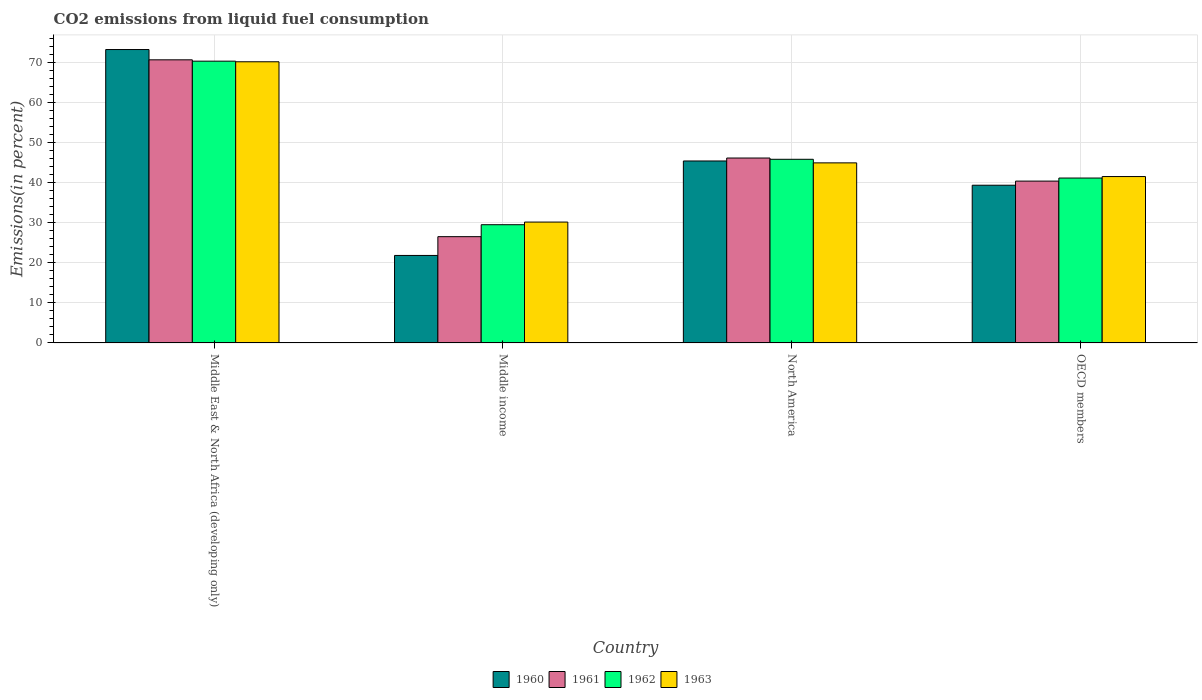How many different coloured bars are there?
Provide a short and direct response. 4. Are the number of bars per tick equal to the number of legend labels?
Your answer should be very brief. Yes. What is the label of the 1st group of bars from the left?
Keep it short and to the point. Middle East & North Africa (developing only). What is the total CO2 emitted in 1961 in North America?
Provide a succinct answer. 46.09. Across all countries, what is the maximum total CO2 emitted in 1960?
Ensure brevity in your answer.  73.13. Across all countries, what is the minimum total CO2 emitted in 1962?
Provide a succinct answer. 29.47. In which country was the total CO2 emitted in 1960 maximum?
Keep it short and to the point. Middle East & North Africa (developing only). What is the total total CO2 emitted in 1960 in the graph?
Provide a succinct answer. 179.61. What is the difference between the total CO2 emitted in 1963 in Middle East & North Africa (developing only) and that in North America?
Make the answer very short. 25.2. What is the difference between the total CO2 emitted in 1963 in Middle East & North Africa (developing only) and the total CO2 emitted in 1962 in North America?
Offer a terse response. 24.31. What is the average total CO2 emitted in 1961 per country?
Make the answer very short. 45.87. What is the difference between the total CO2 emitted of/in 1962 and total CO2 emitted of/in 1963 in Middle income?
Keep it short and to the point. -0.66. In how many countries, is the total CO2 emitted in 1963 greater than 14 %?
Offer a very short reply. 4. What is the ratio of the total CO2 emitted in 1963 in Middle East & North Africa (developing only) to that in OECD members?
Keep it short and to the point. 1.69. What is the difference between the highest and the second highest total CO2 emitted in 1963?
Your answer should be very brief. -3.41. What is the difference between the highest and the lowest total CO2 emitted in 1962?
Make the answer very short. 40.77. Is the sum of the total CO2 emitted in 1962 in Middle income and OECD members greater than the maximum total CO2 emitted in 1960 across all countries?
Make the answer very short. No. What does the 4th bar from the left in North America represents?
Your answer should be very brief. 1963. What does the 4th bar from the right in North America represents?
Offer a terse response. 1960. Is it the case that in every country, the sum of the total CO2 emitted in 1960 and total CO2 emitted in 1962 is greater than the total CO2 emitted in 1963?
Give a very brief answer. Yes. How many bars are there?
Keep it short and to the point. 16. How many countries are there in the graph?
Provide a succinct answer. 4. Does the graph contain grids?
Offer a very short reply. Yes. How many legend labels are there?
Make the answer very short. 4. What is the title of the graph?
Provide a succinct answer. CO2 emissions from liquid fuel consumption. Does "1982" appear as one of the legend labels in the graph?
Your response must be concise. No. What is the label or title of the Y-axis?
Your answer should be very brief. Emissions(in percent). What is the Emissions(in percent) of 1960 in Middle East & North Africa (developing only)?
Ensure brevity in your answer.  73.13. What is the Emissions(in percent) in 1961 in Middle East & North Africa (developing only)?
Provide a succinct answer. 70.57. What is the Emissions(in percent) of 1962 in Middle East & North Africa (developing only)?
Your answer should be very brief. 70.23. What is the Emissions(in percent) in 1963 in Middle East & North Africa (developing only)?
Provide a short and direct response. 70.09. What is the Emissions(in percent) of 1960 in Middle income?
Provide a succinct answer. 21.81. What is the Emissions(in percent) of 1961 in Middle income?
Keep it short and to the point. 26.49. What is the Emissions(in percent) in 1962 in Middle income?
Offer a terse response. 29.47. What is the Emissions(in percent) of 1963 in Middle income?
Your answer should be very brief. 30.13. What is the Emissions(in percent) in 1960 in North America?
Offer a very short reply. 45.36. What is the Emissions(in percent) of 1961 in North America?
Keep it short and to the point. 46.09. What is the Emissions(in percent) in 1962 in North America?
Give a very brief answer. 45.78. What is the Emissions(in percent) of 1963 in North America?
Your answer should be compact. 44.89. What is the Emissions(in percent) in 1960 in OECD members?
Make the answer very short. 39.31. What is the Emissions(in percent) of 1961 in OECD members?
Provide a short and direct response. 40.34. What is the Emissions(in percent) in 1962 in OECD members?
Give a very brief answer. 41.1. What is the Emissions(in percent) in 1963 in OECD members?
Offer a very short reply. 41.48. Across all countries, what is the maximum Emissions(in percent) of 1960?
Provide a succinct answer. 73.13. Across all countries, what is the maximum Emissions(in percent) in 1961?
Give a very brief answer. 70.57. Across all countries, what is the maximum Emissions(in percent) of 1962?
Offer a very short reply. 70.23. Across all countries, what is the maximum Emissions(in percent) in 1963?
Make the answer very short. 70.09. Across all countries, what is the minimum Emissions(in percent) of 1960?
Provide a short and direct response. 21.81. Across all countries, what is the minimum Emissions(in percent) of 1961?
Keep it short and to the point. 26.49. Across all countries, what is the minimum Emissions(in percent) in 1962?
Make the answer very short. 29.47. Across all countries, what is the minimum Emissions(in percent) in 1963?
Your answer should be compact. 30.13. What is the total Emissions(in percent) in 1960 in the graph?
Your response must be concise. 179.61. What is the total Emissions(in percent) in 1961 in the graph?
Offer a very short reply. 183.5. What is the total Emissions(in percent) of 1962 in the graph?
Provide a short and direct response. 186.59. What is the total Emissions(in percent) of 1963 in the graph?
Make the answer very short. 186.58. What is the difference between the Emissions(in percent) of 1960 in Middle East & North Africa (developing only) and that in Middle income?
Your response must be concise. 51.33. What is the difference between the Emissions(in percent) of 1961 in Middle East & North Africa (developing only) and that in Middle income?
Your response must be concise. 44.08. What is the difference between the Emissions(in percent) of 1962 in Middle East & North Africa (developing only) and that in Middle income?
Ensure brevity in your answer.  40.77. What is the difference between the Emissions(in percent) of 1963 in Middle East & North Africa (developing only) and that in Middle income?
Offer a very short reply. 39.96. What is the difference between the Emissions(in percent) in 1960 in Middle East & North Africa (developing only) and that in North America?
Provide a short and direct response. 27.78. What is the difference between the Emissions(in percent) of 1961 in Middle East & North Africa (developing only) and that in North America?
Make the answer very short. 24.48. What is the difference between the Emissions(in percent) of 1962 in Middle East & North Africa (developing only) and that in North America?
Ensure brevity in your answer.  24.46. What is the difference between the Emissions(in percent) in 1963 in Middle East & North Africa (developing only) and that in North America?
Offer a very short reply. 25.2. What is the difference between the Emissions(in percent) in 1960 in Middle East & North Africa (developing only) and that in OECD members?
Offer a very short reply. 33.82. What is the difference between the Emissions(in percent) of 1961 in Middle East & North Africa (developing only) and that in OECD members?
Provide a succinct answer. 30.23. What is the difference between the Emissions(in percent) in 1962 in Middle East & North Africa (developing only) and that in OECD members?
Provide a short and direct response. 29.13. What is the difference between the Emissions(in percent) of 1963 in Middle East & North Africa (developing only) and that in OECD members?
Your response must be concise. 28.61. What is the difference between the Emissions(in percent) of 1960 in Middle income and that in North America?
Give a very brief answer. -23.55. What is the difference between the Emissions(in percent) of 1961 in Middle income and that in North America?
Provide a succinct answer. -19.6. What is the difference between the Emissions(in percent) of 1962 in Middle income and that in North America?
Make the answer very short. -16.31. What is the difference between the Emissions(in percent) of 1963 in Middle income and that in North America?
Your answer should be very brief. -14.76. What is the difference between the Emissions(in percent) of 1960 in Middle income and that in OECD members?
Keep it short and to the point. -17.5. What is the difference between the Emissions(in percent) of 1961 in Middle income and that in OECD members?
Ensure brevity in your answer.  -13.85. What is the difference between the Emissions(in percent) in 1962 in Middle income and that in OECD members?
Keep it short and to the point. -11.64. What is the difference between the Emissions(in percent) in 1963 in Middle income and that in OECD members?
Keep it short and to the point. -11.35. What is the difference between the Emissions(in percent) of 1960 in North America and that in OECD members?
Your answer should be compact. 6.04. What is the difference between the Emissions(in percent) in 1961 in North America and that in OECD members?
Give a very brief answer. 5.75. What is the difference between the Emissions(in percent) in 1962 in North America and that in OECD members?
Keep it short and to the point. 4.67. What is the difference between the Emissions(in percent) of 1963 in North America and that in OECD members?
Ensure brevity in your answer.  3.41. What is the difference between the Emissions(in percent) of 1960 in Middle East & North Africa (developing only) and the Emissions(in percent) of 1961 in Middle income?
Ensure brevity in your answer.  46.64. What is the difference between the Emissions(in percent) in 1960 in Middle East & North Africa (developing only) and the Emissions(in percent) in 1962 in Middle income?
Your response must be concise. 43.66. What is the difference between the Emissions(in percent) of 1960 in Middle East & North Africa (developing only) and the Emissions(in percent) of 1963 in Middle income?
Keep it short and to the point. 43. What is the difference between the Emissions(in percent) in 1961 in Middle East & North Africa (developing only) and the Emissions(in percent) in 1962 in Middle income?
Ensure brevity in your answer.  41.1. What is the difference between the Emissions(in percent) of 1961 in Middle East & North Africa (developing only) and the Emissions(in percent) of 1963 in Middle income?
Offer a terse response. 40.44. What is the difference between the Emissions(in percent) of 1962 in Middle East & North Africa (developing only) and the Emissions(in percent) of 1963 in Middle income?
Your answer should be very brief. 40.11. What is the difference between the Emissions(in percent) in 1960 in Middle East & North Africa (developing only) and the Emissions(in percent) in 1961 in North America?
Give a very brief answer. 27.04. What is the difference between the Emissions(in percent) in 1960 in Middle East & North Africa (developing only) and the Emissions(in percent) in 1962 in North America?
Provide a short and direct response. 27.36. What is the difference between the Emissions(in percent) of 1960 in Middle East & North Africa (developing only) and the Emissions(in percent) of 1963 in North America?
Keep it short and to the point. 28.25. What is the difference between the Emissions(in percent) in 1961 in Middle East & North Africa (developing only) and the Emissions(in percent) in 1962 in North America?
Make the answer very short. 24.79. What is the difference between the Emissions(in percent) of 1961 in Middle East & North Africa (developing only) and the Emissions(in percent) of 1963 in North America?
Your answer should be very brief. 25.69. What is the difference between the Emissions(in percent) of 1962 in Middle East & North Africa (developing only) and the Emissions(in percent) of 1963 in North America?
Provide a short and direct response. 25.35. What is the difference between the Emissions(in percent) in 1960 in Middle East & North Africa (developing only) and the Emissions(in percent) in 1961 in OECD members?
Your answer should be very brief. 32.79. What is the difference between the Emissions(in percent) of 1960 in Middle East & North Africa (developing only) and the Emissions(in percent) of 1962 in OECD members?
Ensure brevity in your answer.  32.03. What is the difference between the Emissions(in percent) of 1960 in Middle East & North Africa (developing only) and the Emissions(in percent) of 1963 in OECD members?
Make the answer very short. 31.66. What is the difference between the Emissions(in percent) of 1961 in Middle East & North Africa (developing only) and the Emissions(in percent) of 1962 in OECD members?
Provide a short and direct response. 29.47. What is the difference between the Emissions(in percent) of 1961 in Middle East & North Africa (developing only) and the Emissions(in percent) of 1963 in OECD members?
Keep it short and to the point. 29.1. What is the difference between the Emissions(in percent) in 1962 in Middle East & North Africa (developing only) and the Emissions(in percent) in 1963 in OECD members?
Ensure brevity in your answer.  28.76. What is the difference between the Emissions(in percent) in 1960 in Middle income and the Emissions(in percent) in 1961 in North America?
Make the answer very short. -24.29. What is the difference between the Emissions(in percent) of 1960 in Middle income and the Emissions(in percent) of 1962 in North America?
Make the answer very short. -23.97. What is the difference between the Emissions(in percent) of 1960 in Middle income and the Emissions(in percent) of 1963 in North America?
Make the answer very short. -23.08. What is the difference between the Emissions(in percent) of 1961 in Middle income and the Emissions(in percent) of 1962 in North America?
Give a very brief answer. -19.29. What is the difference between the Emissions(in percent) in 1961 in Middle income and the Emissions(in percent) in 1963 in North America?
Make the answer very short. -18.39. What is the difference between the Emissions(in percent) in 1962 in Middle income and the Emissions(in percent) in 1963 in North America?
Offer a terse response. -15.42. What is the difference between the Emissions(in percent) of 1960 in Middle income and the Emissions(in percent) of 1961 in OECD members?
Provide a short and direct response. -18.53. What is the difference between the Emissions(in percent) of 1960 in Middle income and the Emissions(in percent) of 1962 in OECD members?
Provide a succinct answer. -19.3. What is the difference between the Emissions(in percent) of 1960 in Middle income and the Emissions(in percent) of 1963 in OECD members?
Offer a very short reply. -19.67. What is the difference between the Emissions(in percent) in 1961 in Middle income and the Emissions(in percent) in 1962 in OECD members?
Offer a terse response. -14.61. What is the difference between the Emissions(in percent) of 1961 in Middle income and the Emissions(in percent) of 1963 in OECD members?
Ensure brevity in your answer.  -14.98. What is the difference between the Emissions(in percent) in 1962 in Middle income and the Emissions(in percent) in 1963 in OECD members?
Provide a succinct answer. -12.01. What is the difference between the Emissions(in percent) in 1960 in North America and the Emissions(in percent) in 1961 in OECD members?
Ensure brevity in your answer.  5.02. What is the difference between the Emissions(in percent) in 1960 in North America and the Emissions(in percent) in 1962 in OECD members?
Your answer should be very brief. 4.25. What is the difference between the Emissions(in percent) of 1960 in North America and the Emissions(in percent) of 1963 in OECD members?
Give a very brief answer. 3.88. What is the difference between the Emissions(in percent) of 1961 in North America and the Emissions(in percent) of 1962 in OECD members?
Ensure brevity in your answer.  4.99. What is the difference between the Emissions(in percent) of 1961 in North America and the Emissions(in percent) of 1963 in OECD members?
Offer a very short reply. 4.62. What is the difference between the Emissions(in percent) in 1962 in North America and the Emissions(in percent) in 1963 in OECD members?
Your answer should be compact. 4.3. What is the average Emissions(in percent) of 1960 per country?
Give a very brief answer. 44.9. What is the average Emissions(in percent) of 1961 per country?
Offer a terse response. 45.87. What is the average Emissions(in percent) in 1962 per country?
Give a very brief answer. 46.65. What is the average Emissions(in percent) of 1963 per country?
Provide a short and direct response. 46.64. What is the difference between the Emissions(in percent) in 1960 and Emissions(in percent) in 1961 in Middle East & North Africa (developing only)?
Make the answer very short. 2.56. What is the difference between the Emissions(in percent) in 1960 and Emissions(in percent) in 1962 in Middle East & North Africa (developing only)?
Provide a short and direct response. 2.9. What is the difference between the Emissions(in percent) of 1960 and Emissions(in percent) of 1963 in Middle East & North Africa (developing only)?
Make the answer very short. 3.05. What is the difference between the Emissions(in percent) in 1961 and Emissions(in percent) in 1962 in Middle East & North Africa (developing only)?
Ensure brevity in your answer.  0.34. What is the difference between the Emissions(in percent) of 1961 and Emissions(in percent) of 1963 in Middle East & North Africa (developing only)?
Your answer should be very brief. 0.48. What is the difference between the Emissions(in percent) of 1962 and Emissions(in percent) of 1963 in Middle East & North Africa (developing only)?
Offer a terse response. 0.15. What is the difference between the Emissions(in percent) of 1960 and Emissions(in percent) of 1961 in Middle income?
Your response must be concise. -4.68. What is the difference between the Emissions(in percent) of 1960 and Emissions(in percent) of 1962 in Middle income?
Offer a very short reply. -7.66. What is the difference between the Emissions(in percent) in 1960 and Emissions(in percent) in 1963 in Middle income?
Make the answer very short. -8.32. What is the difference between the Emissions(in percent) of 1961 and Emissions(in percent) of 1962 in Middle income?
Give a very brief answer. -2.98. What is the difference between the Emissions(in percent) in 1961 and Emissions(in percent) in 1963 in Middle income?
Offer a terse response. -3.64. What is the difference between the Emissions(in percent) in 1962 and Emissions(in percent) in 1963 in Middle income?
Offer a terse response. -0.66. What is the difference between the Emissions(in percent) in 1960 and Emissions(in percent) in 1961 in North America?
Give a very brief answer. -0.74. What is the difference between the Emissions(in percent) in 1960 and Emissions(in percent) in 1962 in North America?
Offer a very short reply. -0.42. What is the difference between the Emissions(in percent) of 1960 and Emissions(in percent) of 1963 in North America?
Your answer should be very brief. 0.47. What is the difference between the Emissions(in percent) of 1961 and Emissions(in percent) of 1962 in North America?
Your answer should be very brief. 0.32. What is the difference between the Emissions(in percent) in 1961 and Emissions(in percent) in 1963 in North America?
Provide a short and direct response. 1.21. What is the difference between the Emissions(in percent) in 1962 and Emissions(in percent) in 1963 in North America?
Ensure brevity in your answer.  0.89. What is the difference between the Emissions(in percent) of 1960 and Emissions(in percent) of 1961 in OECD members?
Make the answer very short. -1.03. What is the difference between the Emissions(in percent) of 1960 and Emissions(in percent) of 1962 in OECD members?
Your answer should be compact. -1.79. What is the difference between the Emissions(in percent) of 1960 and Emissions(in percent) of 1963 in OECD members?
Provide a short and direct response. -2.16. What is the difference between the Emissions(in percent) in 1961 and Emissions(in percent) in 1962 in OECD members?
Your answer should be compact. -0.76. What is the difference between the Emissions(in percent) of 1961 and Emissions(in percent) of 1963 in OECD members?
Offer a very short reply. -1.14. What is the difference between the Emissions(in percent) in 1962 and Emissions(in percent) in 1963 in OECD members?
Provide a short and direct response. -0.37. What is the ratio of the Emissions(in percent) in 1960 in Middle East & North Africa (developing only) to that in Middle income?
Provide a short and direct response. 3.35. What is the ratio of the Emissions(in percent) of 1961 in Middle East & North Africa (developing only) to that in Middle income?
Your answer should be compact. 2.66. What is the ratio of the Emissions(in percent) of 1962 in Middle East & North Africa (developing only) to that in Middle income?
Provide a succinct answer. 2.38. What is the ratio of the Emissions(in percent) of 1963 in Middle East & North Africa (developing only) to that in Middle income?
Your answer should be very brief. 2.33. What is the ratio of the Emissions(in percent) of 1960 in Middle East & North Africa (developing only) to that in North America?
Ensure brevity in your answer.  1.61. What is the ratio of the Emissions(in percent) in 1961 in Middle East & North Africa (developing only) to that in North America?
Your answer should be compact. 1.53. What is the ratio of the Emissions(in percent) in 1962 in Middle East & North Africa (developing only) to that in North America?
Your answer should be very brief. 1.53. What is the ratio of the Emissions(in percent) of 1963 in Middle East & North Africa (developing only) to that in North America?
Make the answer very short. 1.56. What is the ratio of the Emissions(in percent) of 1960 in Middle East & North Africa (developing only) to that in OECD members?
Provide a short and direct response. 1.86. What is the ratio of the Emissions(in percent) of 1961 in Middle East & North Africa (developing only) to that in OECD members?
Give a very brief answer. 1.75. What is the ratio of the Emissions(in percent) of 1962 in Middle East & North Africa (developing only) to that in OECD members?
Your answer should be very brief. 1.71. What is the ratio of the Emissions(in percent) in 1963 in Middle East & North Africa (developing only) to that in OECD members?
Provide a succinct answer. 1.69. What is the ratio of the Emissions(in percent) in 1960 in Middle income to that in North America?
Give a very brief answer. 0.48. What is the ratio of the Emissions(in percent) of 1961 in Middle income to that in North America?
Offer a very short reply. 0.57. What is the ratio of the Emissions(in percent) of 1962 in Middle income to that in North America?
Offer a terse response. 0.64. What is the ratio of the Emissions(in percent) in 1963 in Middle income to that in North America?
Keep it short and to the point. 0.67. What is the ratio of the Emissions(in percent) in 1960 in Middle income to that in OECD members?
Your answer should be very brief. 0.55. What is the ratio of the Emissions(in percent) of 1961 in Middle income to that in OECD members?
Your response must be concise. 0.66. What is the ratio of the Emissions(in percent) in 1962 in Middle income to that in OECD members?
Make the answer very short. 0.72. What is the ratio of the Emissions(in percent) of 1963 in Middle income to that in OECD members?
Your answer should be very brief. 0.73. What is the ratio of the Emissions(in percent) of 1960 in North America to that in OECD members?
Your response must be concise. 1.15. What is the ratio of the Emissions(in percent) in 1961 in North America to that in OECD members?
Your answer should be very brief. 1.14. What is the ratio of the Emissions(in percent) in 1962 in North America to that in OECD members?
Ensure brevity in your answer.  1.11. What is the ratio of the Emissions(in percent) in 1963 in North America to that in OECD members?
Your answer should be compact. 1.08. What is the difference between the highest and the second highest Emissions(in percent) of 1960?
Provide a succinct answer. 27.78. What is the difference between the highest and the second highest Emissions(in percent) in 1961?
Provide a succinct answer. 24.48. What is the difference between the highest and the second highest Emissions(in percent) in 1962?
Your answer should be very brief. 24.46. What is the difference between the highest and the second highest Emissions(in percent) in 1963?
Provide a succinct answer. 25.2. What is the difference between the highest and the lowest Emissions(in percent) in 1960?
Provide a succinct answer. 51.33. What is the difference between the highest and the lowest Emissions(in percent) in 1961?
Keep it short and to the point. 44.08. What is the difference between the highest and the lowest Emissions(in percent) of 1962?
Your answer should be very brief. 40.77. What is the difference between the highest and the lowest Emissions(in percent) in 1963?
Your answer should be compact. 39.96. 